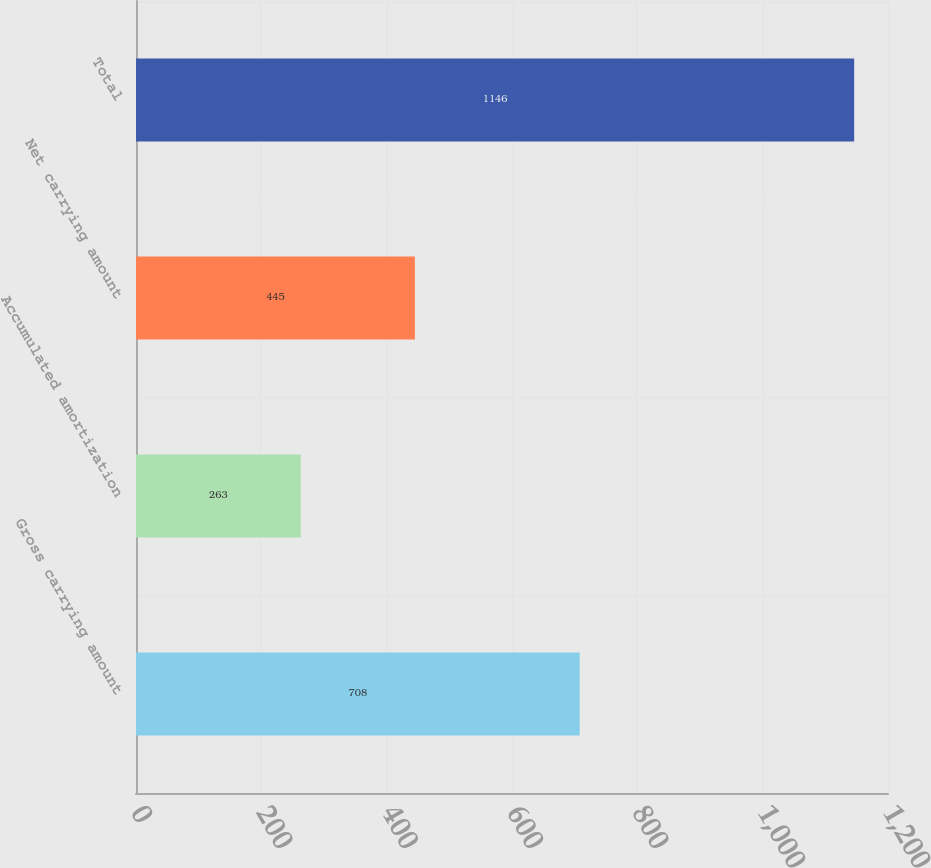Convert chart to OTSL. <chart><loc_0><loc_0><loc_500><loc_500><bar_chart><fcel>Gross carrying amount<fcel>Accumulated amortization<fcel>Net carrying amount<fcel>Total<nl><fcel>708<fcel>263<fcel>445<fcel>1146<nl></chart> 